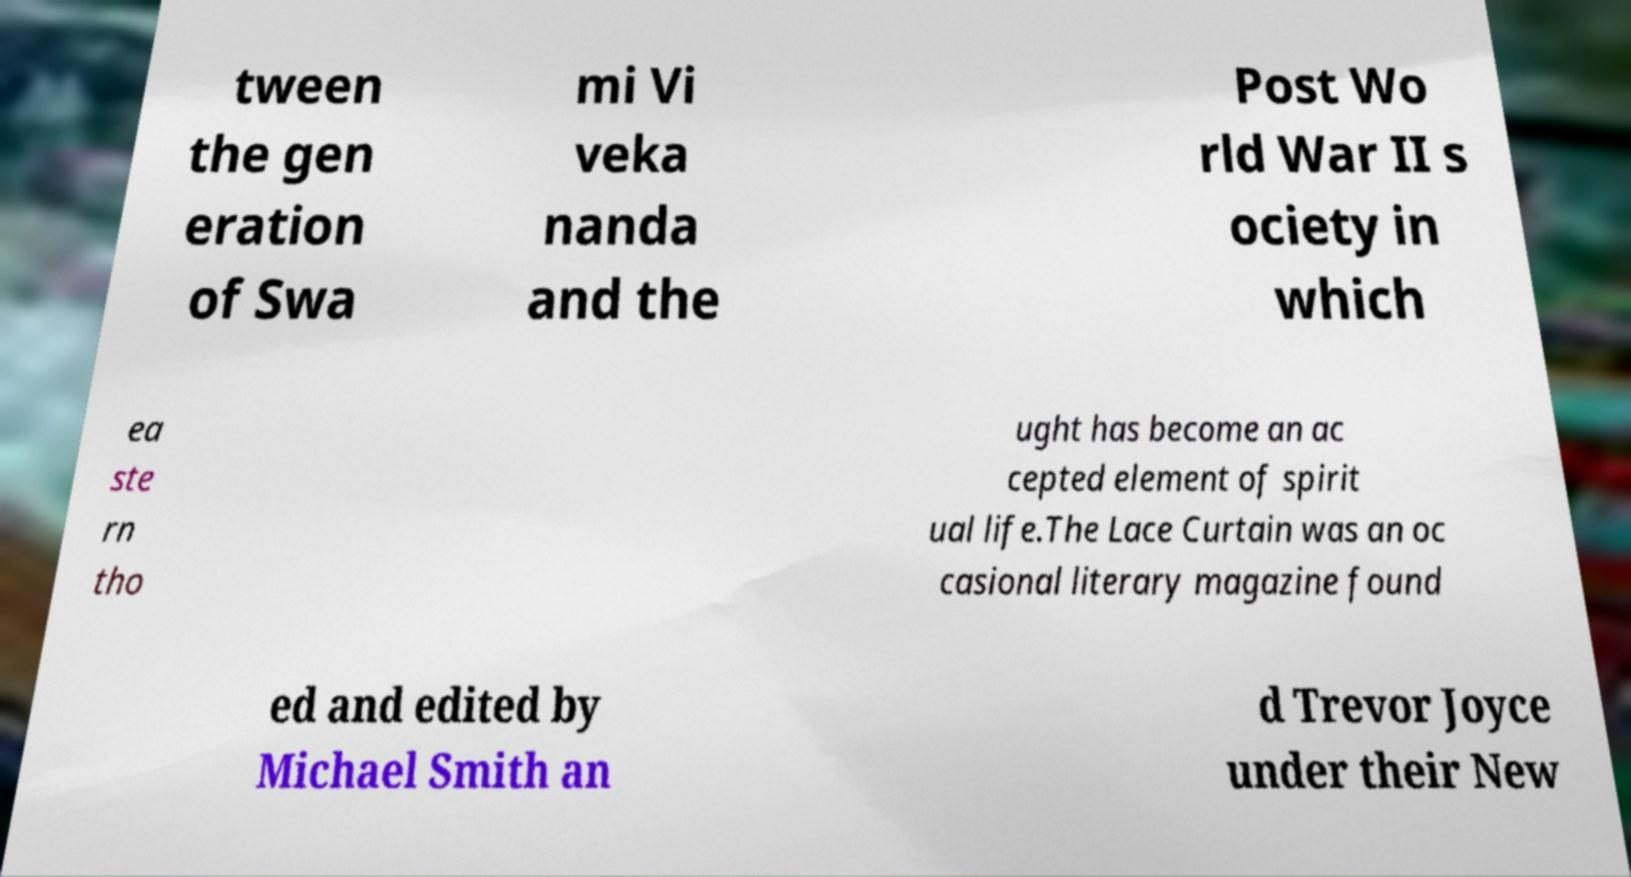What messages or text are displayed in this image? I need them in a readable, typed format. tween the gen eration of Swa mi Vi veka nanda and the Post Wo rld War II s ociety in which ea ste rn tho ught has become an ac cepted element of spirit ual life.The Lace Curtain was an oc casional literary magazine found ed and edited by Michael Smith an d Trevor Joyce under their New 